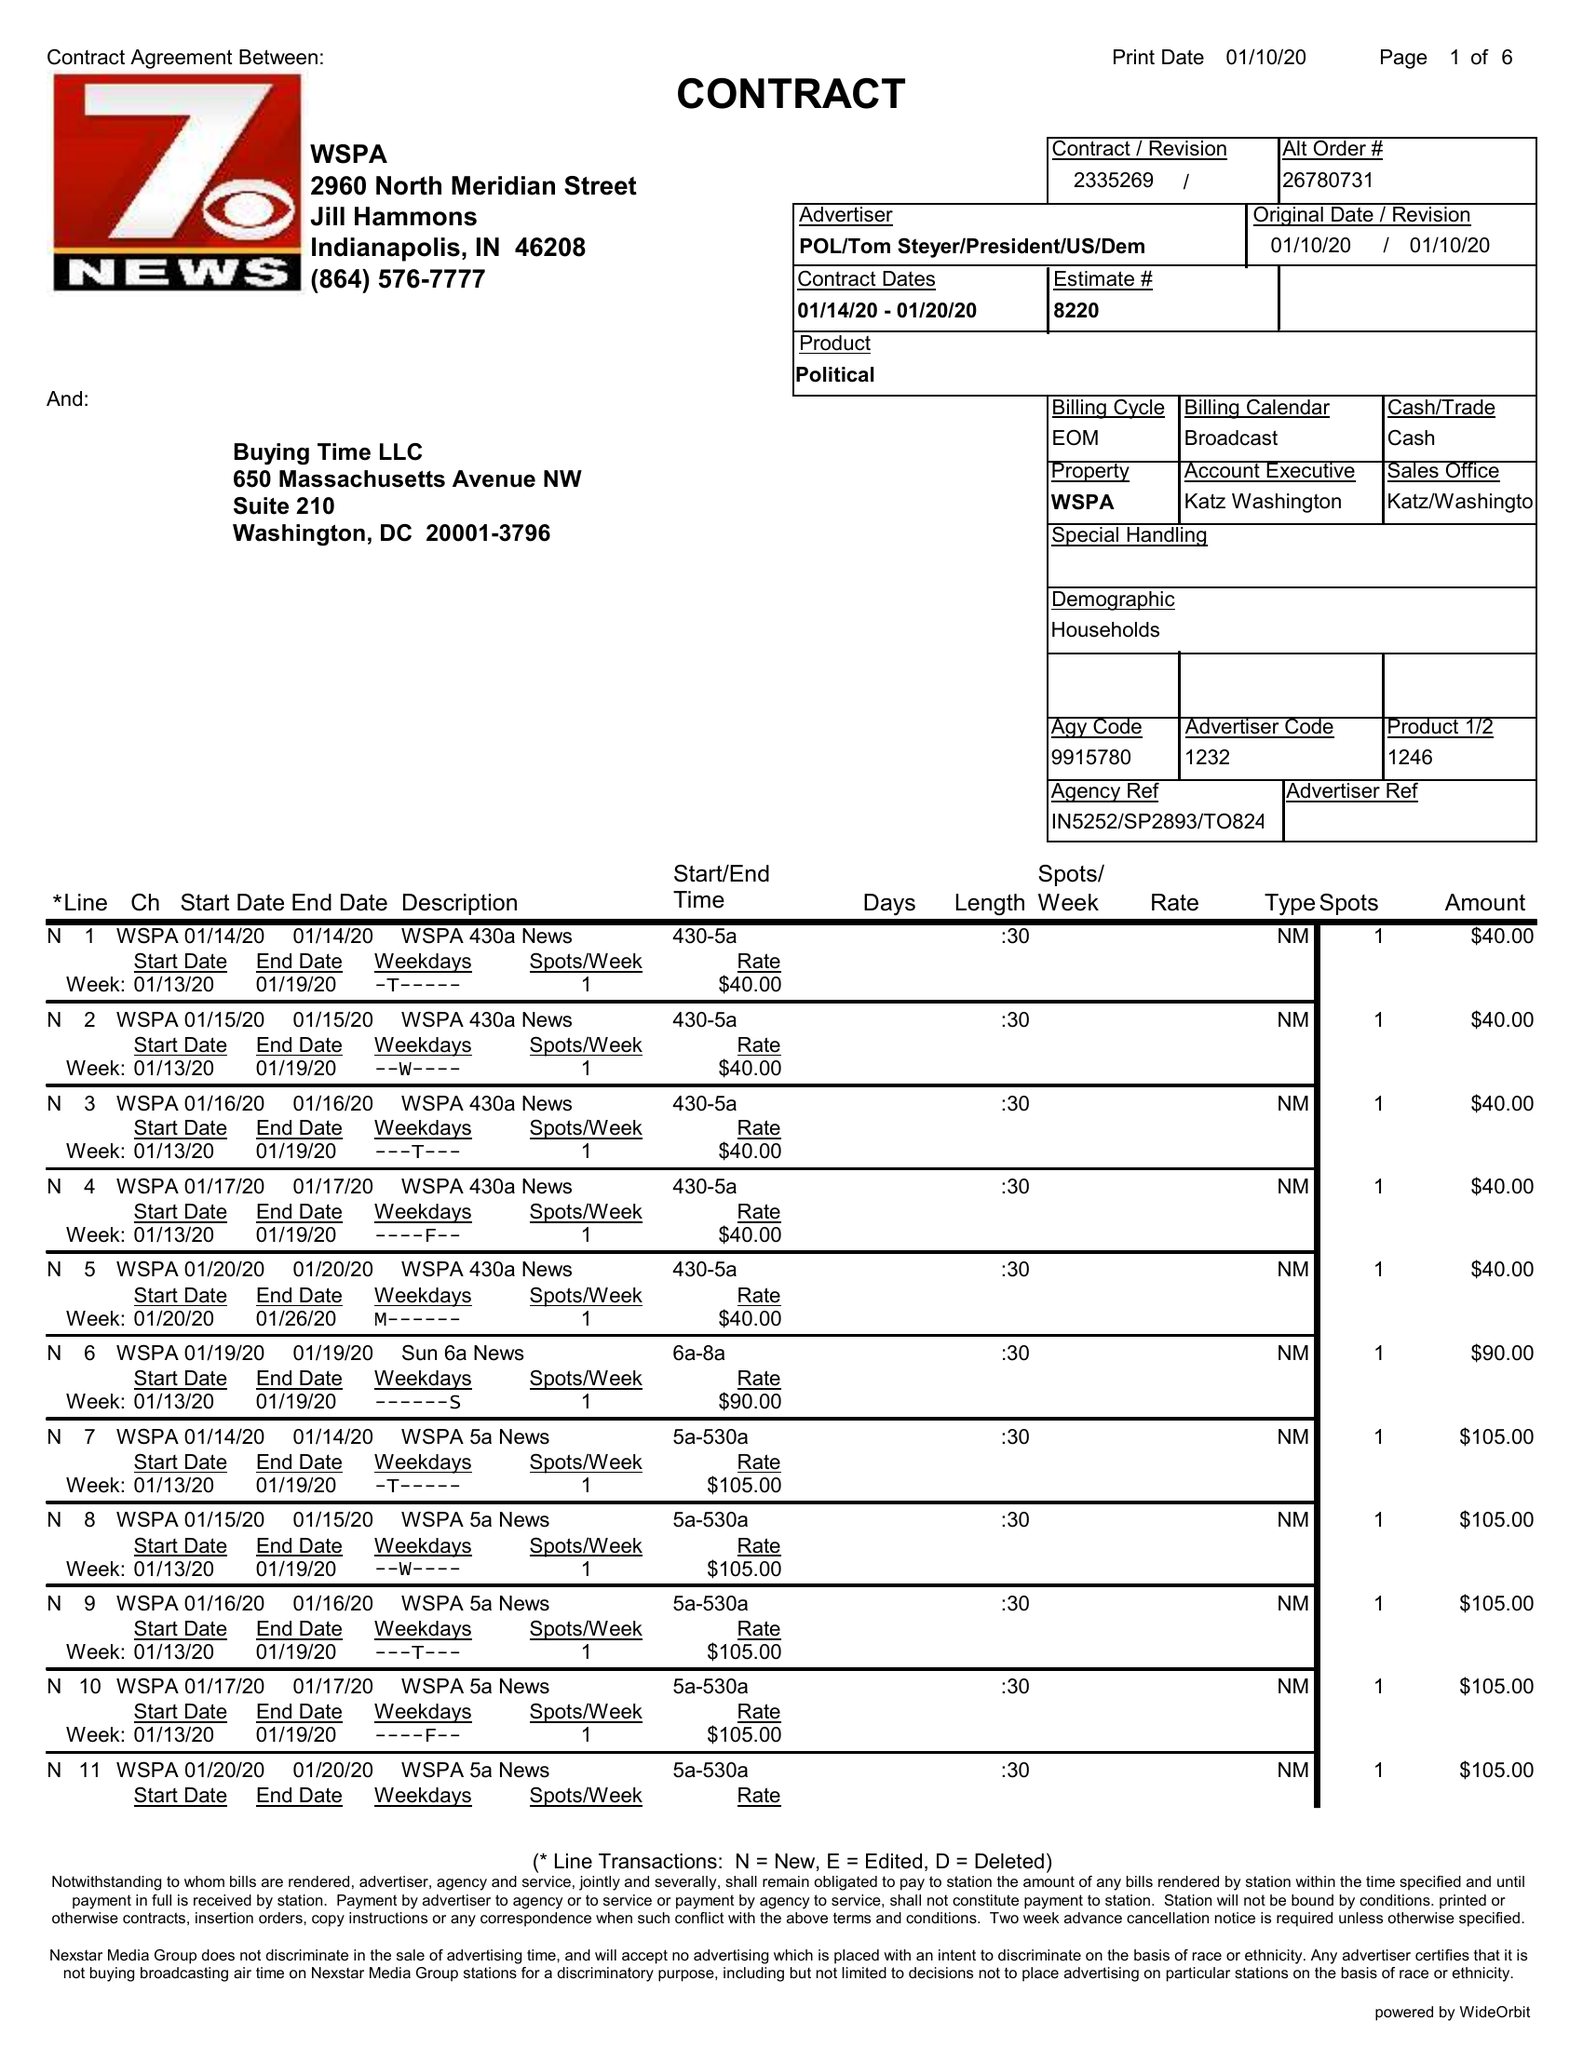What is the value for the gross_amount?
Answer the question using a single word or phrase. 35565.00 